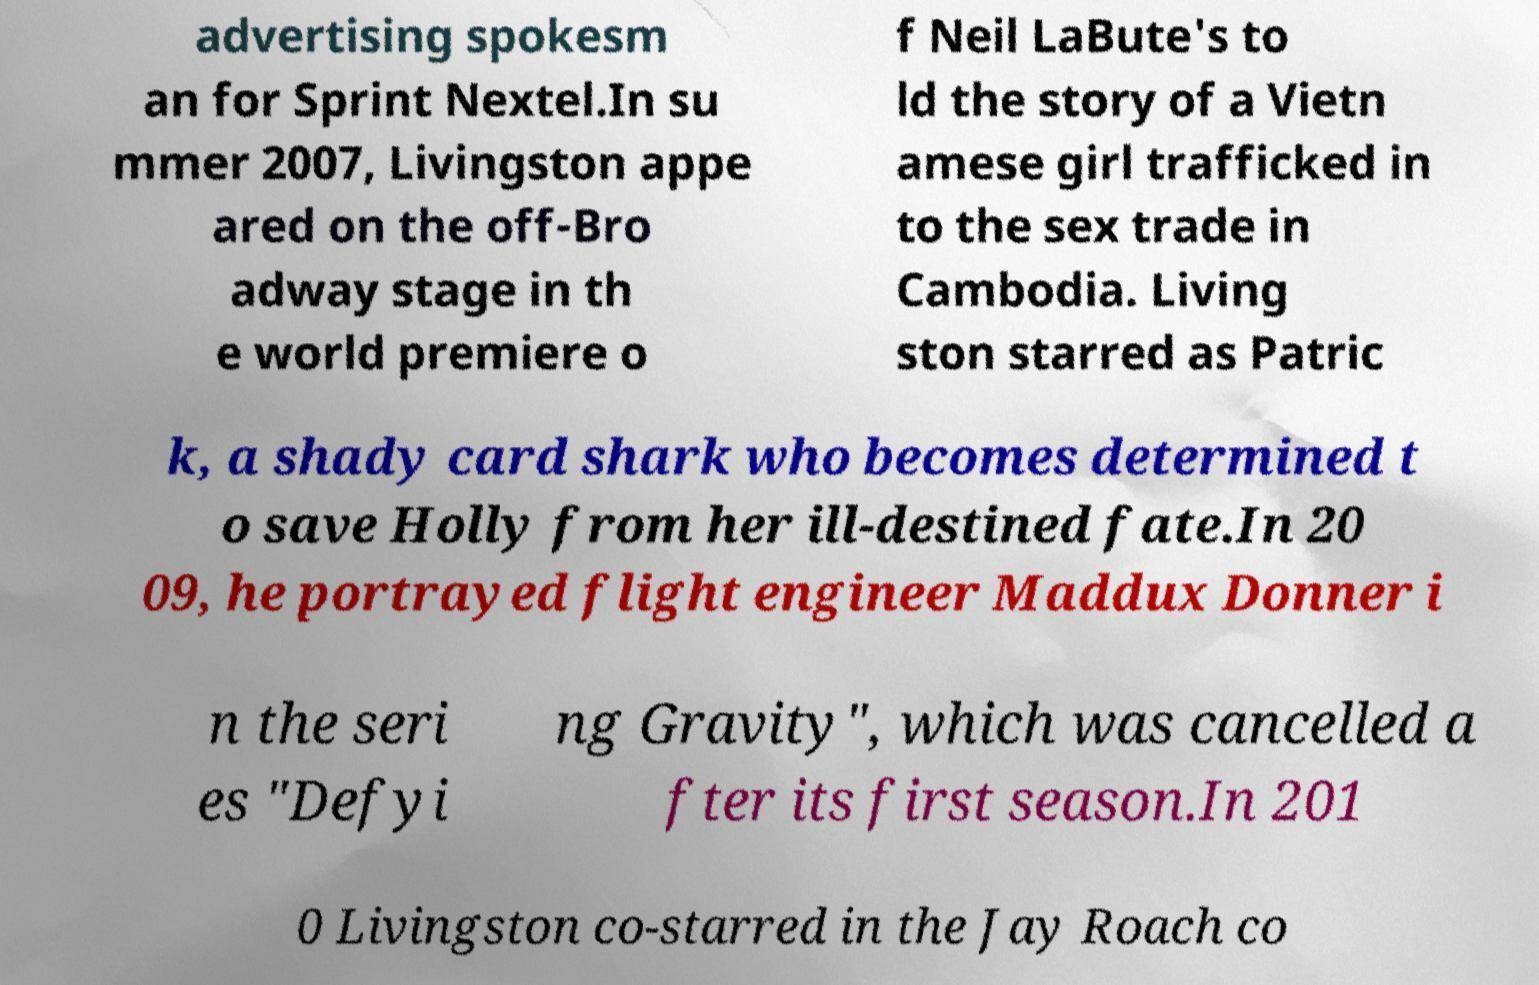For documentation purposes, I need the text within this image transcribed. Could you provide that? advertising spokesm an for Sprint Nextel.In su mmer 2007, Livingston appe ared on the off-Bro adway stage in th e world premiere o f Neil LaBute's to ld the story of a Vietn amese girl trafficked in to the sex trade in Cambodia. Living ston starred as Patric k, a shady card shark who becomes determined t o save Holly from her ill-destined fate.In 20 09, he portrayed flight engineer Maddux Donner i n the seri es "Defyi ng Gravity", which was cancelled a fter its first season.In 201 0 Livingston co-starred in the Jay Roach co 